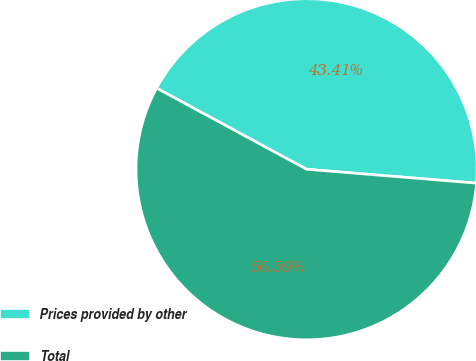Convert chart to OTSL. <chart><loc_0><loc_0><loc_500><loc_500><pie_chart><fcel>Prices provided by other<fcel>Total<nl><fcel>43.41%<fcel>56.59%<nl></chart> 